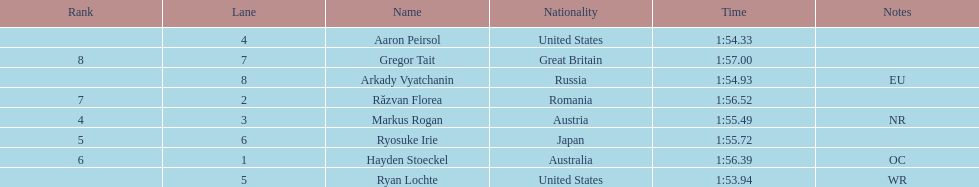Does russia or japan have the longer time? Japan. 